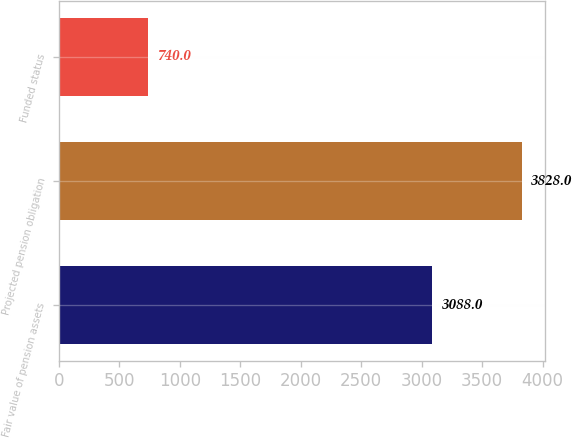Convert chart. <chart><loc_0><loc_0><loc_500><loc_500><bar_chart><fcel>Fair value of pension assets<fcel>Projected pension obligation<fcel>Funded status<nl><fcel>3088<fcel>3828<fcel>740<nl></chart> 